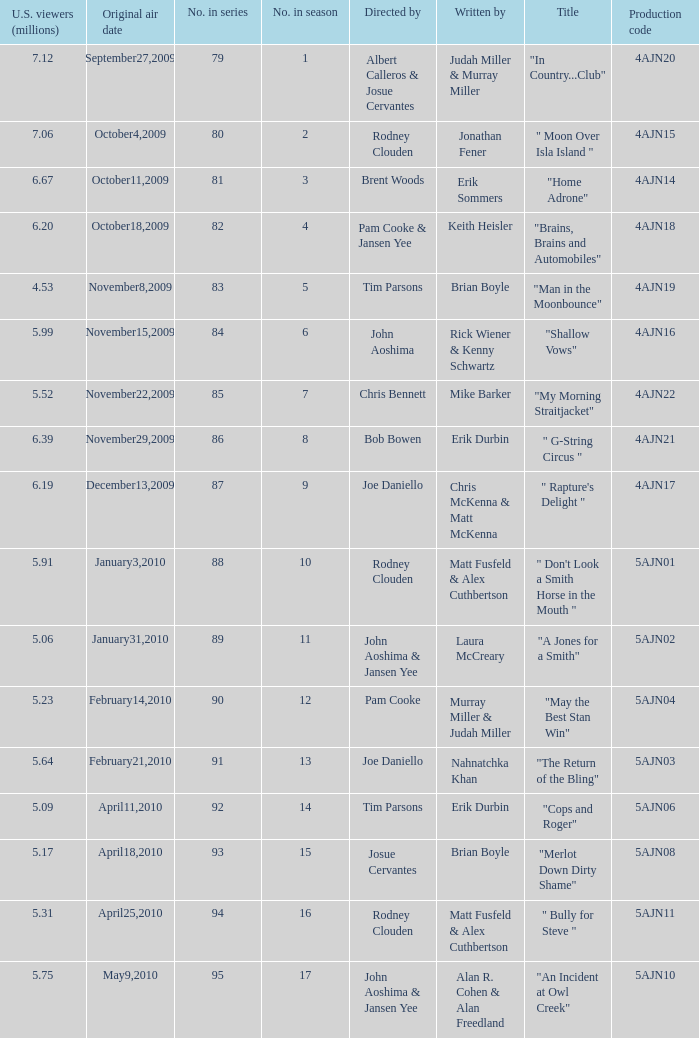Name who wrote the episode directed by  pam cooke & jansen yee Keith Heisler. 